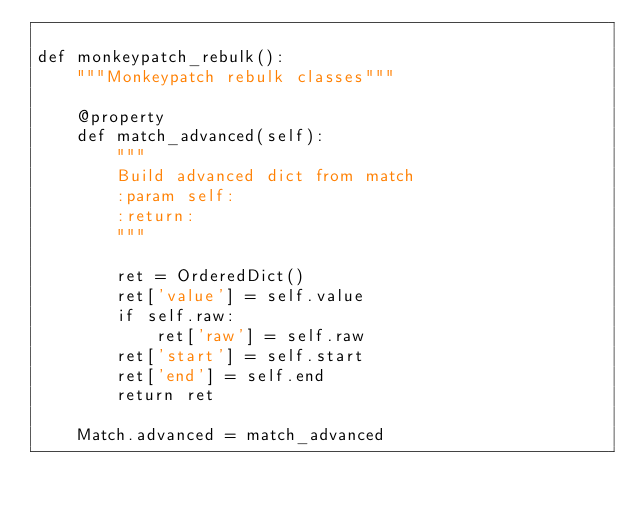Convert code to text. <code><loc_0><loc_0><loc_500><loc_500><_Python_>
def monkeypatch_rebulk():
    """Monkeypatch rebulk classes"""

    @property
    def match_advanced(self):
        """
        Build advanced dict from match
        :param self:
        :return:
        """

        ret = OrderedDict()
        ret['value'] = self.value
        if self.raw:
            ret['raw'] = self.raw
        ret['start'] = self.start
        ret['end'] = self.end
        return ret

    Match.advanced = match_advanced
</code> 